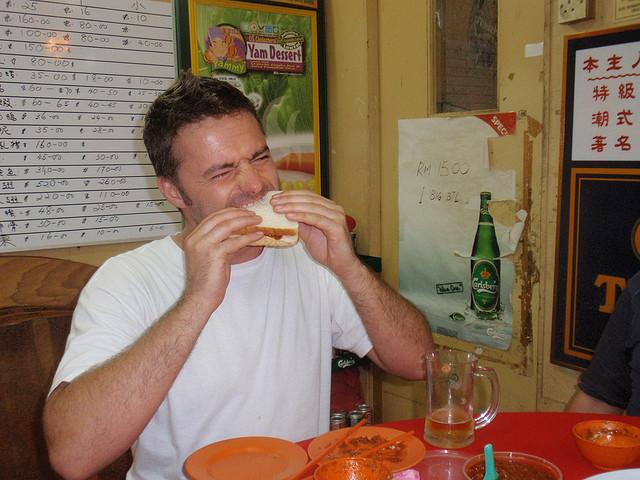What is the man eating?
Keep it brief. Sandwich. Which continent is this man probably on?
Be succinct. Asia. How many orange dishes in the picture?
Answer briefly. 4. How many men are shown?
Short answer required. 1. What race is this man?
Answer briefly. White. 